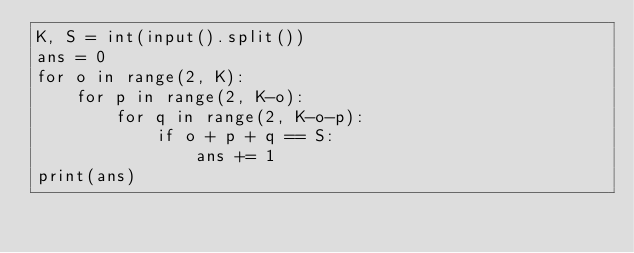Convert code to text. <code><loc_0><loc_0><loc_500><loc_500><_Python_>K, S = int(input().split())
ans = 0
for o in range(2, K):
    for p in range(2, K-o):
        for q in range(2, K-o-p):
            if o + p + q == S:
                ans += 1
print(ans)
</code> 